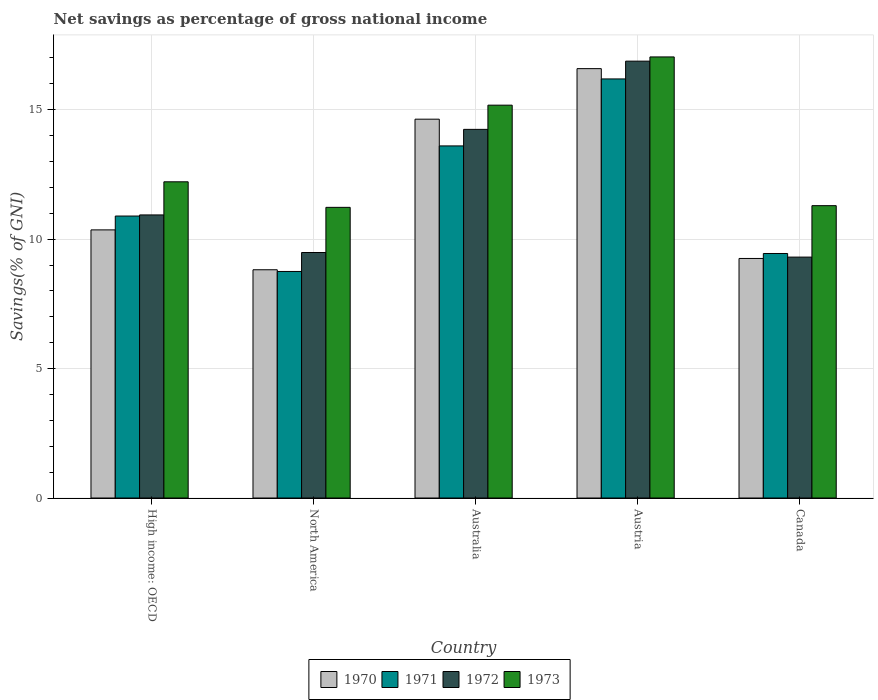How many different coloured bars are there?
Give a very brief answer. 4. How many groups of bars are there?
Keep it short and to the point. 5. Are the number of bars per tick equal to the number of legend labels?
Your response must be concise. Yes. Are the number of bars on each tick of the X-axis equal?
Provide a succinct answer. Yes. How many bars are there on the 4th tick from the left?
Offer a very short reply. 4. How many bars are there on the 3rd tick from the right?
Your answer should be compact. 4. What is the label of the 5th group of bars from the left?
Provide a succinct answer. Canada. In how many cases, is the number of bars for a given country not equal to the number of legend labels?
Provide a succinct answer. 0. What is the total savings in 1972 in Australia?
Ensure brevity in your answer.  14.24. Across all countries, what is the maximum total savings in 1972?
Your answer should be very brief. 16.88. Across all countries, what is the minimum total savings in 1973?
Your response must be concise. 11.23. In which country was the total savings in 1971 maximum?
Your response must be concise. Austria. What is the total total savings in 1970 in the graph?
Offer a very short reply. 59.65. What is the difference between the total savings in 1971 in Austria and that in Canada?
Ensure brevity in your answer.  6.74. What is the difference between the total savings in 1973 in Australia and the total savings in 1970 in High income: OECD?
Make the answer very short. 4.82. What is the average total savings in 1971 per country?
Your response must be concise. 11.78. What is the difference between the total savings of/in 1972 and total savings of/in 1970 in High income: OECD?
Offer a terse response. 0.58. What is the ratio of the total savings in 1970 in Austria to that in High income: OECD?
Your answer should be compact. 1.6. Is the total savings in 1970 in Australia less than that in High income: OECD?
Make the answer very short. No. Is the difference between the total savings in 1972 in Austria and High income: OECD greater than the difference between the total savings in 1970 in Austria and High income: OECD?
Provide a succinct answer. No. What is the difference between the highest and the second highest total savings in 1972?
Your response must be concise. 5.94. What is the difference between the highest and the lowest total savings in 1970?
Give a very brief answer. 7.77. Is it the case that in every country, the sum of the total savings in 1971 and total savings in 1973 is greater than the sum of total savings in 1970 and total savings in 1972?
Your answer should be compact. No. What does the 3rd bar from the right in Canada represents?
Your response must be concise. 1971. Is it the case that in every country, the sum of the total savings in 1971 and total savings in 1973 is greater than the total savings in 1972?
Offer a terse response. Yes. Are all the bars in the graph horizontal?
Give a very brief answer. No. How many countries are there in the graph?
Your response must be concise. 5. What is the difference between two consecutive major ticks on the Y-axis?
Your response must be concise. 5. Are the values on the major ticks of Y-axis written in scientific E-notation?
Ensure brevity in your answer.  No. Does the graph contain grids?
Give a very brief answer. Yes. What is the title of the graph?
Keep it short and to the point. Net savings as percentage of gross national income. What is the label or title of the X-axis?
Offer a very short reply. Country. What is the label or title of the Y-axis?
Offer a very short reply. Savings(% of GNI). What is the Savings(% of GNI) of 1970 in High income: OECD?
Offer a very short reply. 10.36. What is the Savings(% of GNI) in 1971 in High income: OECD?
Offer a very short reply. 10.89. What is the Savings(% of GNI) in 1972 in High income: OECD?
Provide a short and direct response. 10.94. What is the Savings(% of GNI) of 1973 in High income: OECD?
Provide a short and direct response. 12.22. What is the Savings(% of GNI) of 1970 in North America?
Keep it short and to the point. 8.82. What is the Savings(% of GNI) in 1971 in North America?
Ensure brevity in your answer.  8.75. What is the Savings(% of GNI) in 1972 in North America?
Your answer should be very brief. 9.48. What is the Savings(% of GNI) of 1973 in North America?
Ensure brevity in your answer.  11.23. What is the Savings(% of GNI) of 1970 in Australia?
Your answer should be compact. 14.63. What is the Savings(% of GNI) in 1971 in Australia?
Your answer should be compact. 13.6. What is the Savings(% of GNI) of 1972 in Australia?
Your answer should be very brief. 14.24. What is the Savings(% of GNI) in 1973 in Australia?
Your response must be concise. 15.18. What is the Savings(% of GNI) of 1970 in Austria?
Provide a short and direct response. 16.59. What is the Savings(% of GNI) of 1971 in Austria?
Offer a very short reply. 16.19. What is the Savings(% of GNI) in 1972 in Austria?
Make the answer very short. 16.88. What is the Savings(% of GNI) in 1973 in Austria?
Provide a succinct answer. 17.04. What is the Savings(% of GNI) in 1970 in Canada?
Provide a short and direct response. 9.25. What is the Savings(% of GNI) of 1971 in Canada?
Offer a very short reply. 9.45. What is the Savings(% of GNI) in 1972 in Canada?
Offer a terse response. 9.31. What is the Savings(% of GNI) in 1973 in Canada?
Keep it short and to the point. 11.29. Across all countries, what is the maximum Savings(% of GNI) in 1970?
Give a very brief answer. 16.59. Across all countries, what is the maximum Savings(% of GNI) in 1971?
Make the answer very short. 16.19. Across all countries, what is the maximum Savings(% of GNI) in 1972?
Your response must be concise. 16.88. Across all countries, what is the maximum Savings(% of GNI) in 1973?
Your answer should be compact. 17.04. Across all countries, what is the minimum Savings(% of GNI) of 1970?
Provide a succinct answer. 8.82. Across all countries, what is the minimum Savings(% of GNI) in 1971?
Provide a short and direct response. 8.75. Across all countries, what is the minimum Savings(% of GNI) of 1972?
Offer a very short reply. 9.31. Across all countries, what is the minimum Savings(% of GNI) in 1973?
Your answer should be very brief. 11.23. What is the total Savings(% of GNI) in 1970 in the graph?
Provide a short and direct response. 59.65. What is the total Savings(% of GNI) of 1971 in the graph?
Offer a terse response. 58.88. What is the total Savings(% of GNI) of 1972 in the graph?
Keep it short and to the point. 60.84. What is the total Savings(% of GNI) in 1973 in the graph?
Keep it short and to the point. 66.95. What is the difference between the Savings(% of GNI) of 1970 in High income: OECD and that in North America?
Provide a short and direct response. 1.54. What is the difference between the Savings(% of GNI) of 1971 in High income: OECD and that in North America?
Ensure brevity in your answer.  2.14. What is the difference between the Savings(% of GNI) in 1972 in High income: OECD and that in North America?
Provide a succinct answer. 1.45. What is the difference between the Savings(% of GNI) in 1973 in High income: OECD and that in North America?
Keep it short and to the point. 0.99. What is the difference between the Savings(% of GNI) of 1970 in High income: OECD and that in Australia?
Keep it short and to the point. -4.28. What is the difference between the Savings(% of GNI) of 1971 in High income: OECD and that in Australia?
Keep it short and to the point. -2.71. What is the difference between the Savings(% of GNI) of 1972 in High income: OECD and that in Australia?
Make the answer very short. -3.31. What is the difference between the Savings(% of GNI) of 1973 in High income: OECD and that in Australia?
Your answer should be compact. -2.96. What is the difference between the Savings(% of GNI) of 1970 in High income: OECD and that in Austria?
Provide a short and direct response. -6.23. What is the difference between the Savings(% of GNI) in 1971 in High income: OECD and that in Austria?
Provide a succinct answer. -5.3. What is the difference between the Savings(% of GNI) in 1972 in High income: OECD and that in Austria?
Offer a terse response. -5.94. What is the difference between the Savings(% of GNI) of 1973 in High income: OECD and that in Austria?
Keep it short and to the point. -4.82. What is the difference between the Savings(% of GNI) of 1970 in High income: OECD and that in Canada?
Make the answer very short. 1.1. What is the difference between the Savings(% of GNI) in 1971 in High income: OECD and that in Canada?
Offer a terse response. 1.45. What is the difference between the Savings(% of GNI) of 1972 in High income: OECD and that in Canada?
Provide a succinct answer. 1.63. What is the difference between the Savings(% of GNI) of 1973 in High income: OECD and that in Canada?
Offer a terse response. 0.92. What is the difference between the Savings(% of GNI) of 1970 in North America and that in Australia?
Ensure brevity in your answer.  -5.82. What is the difference between the Savings(% of GNI) in 1971 in North America and that in Australia?
Your answer should be compact. -4.85. What is the difference between the Savings(% of GNI) in 1972 in North America and that in Australia?
Your answer should be compact. -4.76. What is the difference between the Savings(% of GNI) in 1973 in North America and that in Australia?
Offer a terse response. -3.95. What is the difference between the Savings(% of GNI) in 1970 in North America and that in Austria?
Offer a terse response. -7.77. What is the difference between the Savings(% of GNI) in 1971 in North America and that in Austria?
Ensure brevity in your answer.  -7.44. What is the difference between the Savings(% of GNI) of 1972 in North America and that in Austria?
Keep it short and to the point. -7.39. What is the difference between the Savings(% of GNI) of 1973 in North America and that in Austria?
Your response must be concise. -5.81. What is the difference between the Savings(% of GNI) in 1970 in North America and that in Canada?
Make the answer very short. -0.44. What is the difference between the Savings(% of GNI) in 1971 in North America and that in Canada?
Provide a short and direct response. -0.69. What is the difference between the Savings(% of GNI) in 1972 in North America and that in Canada?
Make the answer very short. 0.18. What is the difference between the Savings(% of GNI) of 1973 in North America and that in Canada?
Provide a succinct answer. -0.07. What is the difference between the Savings(% of GNI) of 1970 in Australia and that in Austria?
Ensure brevity in your answer.  -1.95. What is the difference between the Savings(% of GNI) in 1971 in Australia and that in Austria?
Make the answer very short. -2.59. What is the difference between the Savings(% of GNI) of 1972 in Australia and that in Austria?
Your answer should be very brief. -2.64. What is the difference between the Savings(% of GNI) in 1973 in Australia and that in Austria?
Offer a terse response. -1.86. What is the difference between the Savings(% of GNI) of 1970 in Australia and that in Canada?
Provide a short and direct response. 5.38. What is the difference between the Savings(% of GNI) of 1971 in Australia and that in Canada?
Your response must be concise. 4.16. What is the difference between the Savings(% of GNI) of 1972 in Australia and that in Canada?
Provide a succinct answer. 4.93. What is the difference between the Savings(% of GNI) of 1973 in Australia and that in Canada?
Keep it short and to the point. 3.88. What is the difference between the Savings(% of GNI) in 1970 in Austria and that in Canada?
Give a very brief answer. 7.33. What is the difference between the Savings(% of GNI) of 1971 in Austria and that in Canada?
Make the answer very short. 6.74. What is the difference between the Savings(% of GNI) in 1972 in Austria and that in Canada?
Give a very brief answer. 7.57. What is the difference between the Savings(% of GNI) of 1973 in Austria and that in Canada?
Offer a terse response. 5.75. What is the difference between the Savings(% of GNI) in 1970 in High income: OECD and the Savings(% of GNI) in 1971 in North America?
Your response must be concise. 1.61. What is the difference between the Savings(% of GNI) in 1970 in High income: OECD and the Savings(% of GNI) in 1972 in North America?
Keep it short and to the point. 0.87. What is the difference between the Savings(% of GNI) in 1970 in High income: OECD and the Savings(% of GNI) in 1973 in North America?
Ensure brevity in your answer.  -0.87. What is the difference between the Savings(% of GNI) of 1971 in High income: OECD and the Savings(% of GNI) of 1972 in North America?
Provide a succinct answer. 1.41. What is the difference between the Savings(% of GNI) in 1971 in High income: OECD and the Savings(% of GNI) in 1973 in North America?
Your answer should be compact. -0.34. What is the difference between the Savings(% of GNI) in 1972 in High income: OECD and the Savings(% of GNI) in 1973 in North America?
Offer a terse response. -0.29. What is the difference between the Savings(% of GNI) in 1970 in High income: OECD and the Savings(% of GNI) in 1971 in Australia?
Your answer should be very brief. -3.24. What is the difference between the Savings(% of GNI) of 1970 in High income: OECD and the Savings(% of GNI) of 1972 in Australia?
Give a very brief answer. -3.88. What is the difference between the Savings(% of GNI) in 1970 in High income: OECD and the Savings(% of GNI) in 1973 in Australia?
Provide a short and direct response. -4.82. What is the difference between the Savings(% of GNI) in 1971 in High income: OECD and the Savings(% of GNI) in 1972 in Australia?
Keep it short and to the point. -3.35. What is the difference between the Savings(% of GNI) of 1971 in High income: OECD and the Savings(% of GNI) of 1973 in Australia?
Offer a very short reply. -4.28. What is the difference between the Savings(% of GNI) in 1972 in High income: OECD and the Savings(% of GNI) in 1973 in Australia?
Provide a succinct answer. -4.24. What is the difference between the Savings(% of GNI) of 1970 in High income: OECD and the Savings(% of GNI) of 1971 in Austria?
Provide a short and direct response. -5.83. What is the difference between the Savings(% of GNI) of 1970 in High income: OECD and the Savings(% of GNI) of 1972 in Austria?
Your answer should be compact. -6.52. What is the difference between the Savings(% of GNI) in 1970 in High income: OECD and the Savings(% of GNI) in 1973 in Austria?
Your response must be concise. -6.68. What is the difference between the Savings(% of GNI) in 1971 in High income: OECD and the Savings(% of GNI) in 1972 in Austria?
Give a very brief answer. -5.98. What is the difference between the Savings(% of GNI) of 1971 in High income: OECD and the Savings(% of GNI) of 1973 in Austria?
Ensure brevity in your answer.  -6.15. What is the difference between the Savings(% of GNI) in 1972 in High income: OECD and the Savings(% of GNI) in 1973 in Austria?
Provide a succinct answer. -6.1. What is the difference between the Savings(% of GNI) in 1970 in High income: OECD and the Savings(% of GNI) in 1971 in Canada?
Provide a succinct answer. 0.91. What is the difference between the Savings(% of GNI) in 1970 in High income: OECD and the Savings(% of GNI) in 1972 in Canada?
Ensure brevity in your answer.  1.05. What is the difference between the Savings(% of GNI) of 1970 in High income: OECD and the Savings(% of GNI) of 1973 in Canada?
Provide a short and direct response. -0.94. What is the difference between the Savings(% of GNI) in 1971 in High income: OECD and the Savings(% of GNI) in 1972 in Canada?
Your answer should be compact. 1.59. What is the difference between the Savings(% of GNI) of 1971 in High income: OECD and the Savings(% of GNI) of 1973 in Canada?
Keep it short and to the point. -0.4. What is the difference between the Savings(% of GNI) in 1972 in High income: OECD and the Savings(% of GNI) in 1973 in Canada?
Provide a short and direct response. -0.36. What is the difference between the Savings(% of GNI) in 1970 in North America and the Savings(% of GNI) in 1971 in Australia?
Make the answer very short. -4.78. What is the difference between the Savings(% of GNI) of 1970 in North America and the Savings(% of GNI) of 1972 in Australia?
Your answer should be compact. -5.42. What is the difference between the Savings(% of GNI) of 1970 in North America and the Savings(% of GNI) of 1973 in Australia?
Offer a terse response. -6.36. What is the difference between the Savings(% of GNI) of 1971 in North America and the Savings(% of GNI) of 1972 in Australia?
Your response must be concise. -5.49. What is the difference between the Savings(% of GNI) in 1971 in North America and the Savings(% of GNI) in 1973 in Australia?
Your response must be concise. -6.42. What is the difference between the Savings(% of GNI) of 1972 in North America and the Savings(% of GNI) of 1973 in Australia?
Offer a very short reply. -5.69. What is the difference between the Savings(% of GNI) of 1970 in North America and the Savings(% of GNI) of 1971 in Austria?
Your response must be concise. -7.37. What is the difference between the Savings(% of GNI) of 1970 in North America and the Savings(% of GNI) of 1972 in Austria?
Your answer should be compact. -8.06. What is the difference between the Savings(% of GNI) in 1970 in North America and the Savings(% of GNI) in 1973 in Austria?
Provide a short and direct response. -8.22. What is the difference between the Savings(% of GNI) in 1971 in North America and the Savings(% of GNI) in 1972 in Austria?
Your answer should be very brief. -8.12. What is the difference between the Savings(% of GNI) of 1971 in North America and the Savings(% of GNI) of 1973 in Austria?
Your answer should be compact. -8.29. What is the difference between the Savings(% of GNI) in 1972 in North America and the Savings(% of GNI) in 1973 in Austria?
Your answer should be very brief. -7.56. What is the difference between the Savings(% of GNI) of 1970 in North America and the Savings(% of GNI) of 1971 in Canada?
Provide a succinct answer. -0.63. What is the difference between the Savings(% of GNI) of 1970 in North America and the Savings(% of GNI) of 1972 in Canada?
Your answer should be compact. -0.49. What is the difference between the Savings(% of GNI) in 1970 in North America and the Savings(% of GNI) in 1973 in Canada?
Provide a succinct answer. -2.48. What is the difference between the Savings(% of GNI) in 1971 in North America and the Savings(% of GNI) in 1972 in Canada?
Keep it short and to the point. -0.55. What is the difference between the Savings(% of GNI) in 1971 in North America and the Savings(% of GNI) in 1973 in Canada?
Make the answer very short. -2.54. What is the difference between the Savings(% of GNI) in 1972 in North America and the Savings(% of GNI) in 1973 in Canada?
Offer a very short reply. -1.81. What is the difference between the Savings(% of GNI) in 1970 in Australia and the Savings(% of GNI) in 1971 in Austria?
Ensure brevity in your answer.  -1.55. What is the difference between the Savings(% of GNI) in 1970 in Australia and the Savings(% of GNI) in 1972 in Austria?
Give a very brief answer. -2.24. What is the difference between the Savings(% of GNI) in 1970 in Australia and the Savings(% of GNI) in 1973 in Austria?
Keep it short and to the point. -2.4. What is the difference between the Savings(% of GNI) in 1971 in Australia and the Savings(% of GNI) in 1972 in Austria?
Your answer should be compact. -3.27. What is the difference between the Savings(% of GNI) of 1971 in Australia and the Savings(% of GNI) of 1973 in Austria?
Give a very brief answer. -3.44. What is the difference between the Savings(% of GNI) in 1972 in Australia and the Savings(% of GNI) in 1973 in Austria?
Provide a succinct answer. -2.8. What is the difference between the Savings(% of GNI) of 1970 in Australia and the Savings(% of GNI) of 1971 in Canada?
Give a very brief answer. 5.19. What is the difference between the Savings(% of GNI) of 1970 in Australia and the Savings(% of GNI) of 1972 in Canada?
Your answer should be very brief. 5.33. What is the difference between the Savings(% of GNI) in 1970 in Australia and the Savings(% of GNI) in 1973 in Canada?
Your answer should be very brief. 3.34. What is the difference between the Savings(% of GNI) in 1971 in Australia and the Savings(% of GNI) in 1972 in Canada?
Your response must be concise. 4.3. What is the difference between the Savings(% of GNI) of 1971 in Australia and the Savings(% of GNI) of 1973 in Canada?
Your response must be concise. 2.31. What is the difference between the Savings(% of GNI) in 1972 in Australia and the Savings(% of GNI) in 1973 in Canada?
Your response must be concise. 2.95. What is the difference between the Savings(% of GNI) in 1970 in Austria and the Savings(% of GNI) in 1971 in Canada?
Your answer should be very brief. 7.14. What is the difference between the Savings(% of GNI) of 1970 in Austria and the Savings(% of GNI) of 1972 in Canada?
Offer a very short reply. 7.28. What is the difference between the Savings(% of GNI) in 1970 in Austria and the Savings(% of GNI) in 1973 in Canada?
Give a very brief answer. 5.29. What is the difference between the Savings(% of GNI) of 1971 in Austria and the Savings(% of GNI) of 1972 in Canada?
Give a very brief answer. 6.88. What is the difference between the Savings(% of GNI) in 1971 in Austria and the Savings(% of GNI) in 1973 in Canada?
Your response must be concise. 4.9. What is the difference between the Savings(% of GNI) of 1972 in Austria and the Savings(% of GNI) of 1973 in Canada?
Your answer should be very brief. 5.58. What is the average Savings(% of GNI) in 1970 per country?
Ensure brevity in your answer.  11.93. What is the average Savings(% of GNI) in 1971 per country?
Ensure brevity in your answer.  11.78. What is the average Savings(% of GNI) in 1972 per country?
Provide a short and direct response. 12.17. What is the average Savings(% of GNI) of 1973 per country?
Offer a terse response. 13.39. What is the difference between the Savings(% of GNI) in 1970 and Savings(% of GNI) in 1971 in High income: OECD?
Provide a short and direct response. -0.53. What is the difference between the Savings(% of GNI) in 1970 and Savings(% of GNI) in 1972 in High income: OECD?
Offer a terse response. -0.58. What is the difference between the Savings(% of GNI) in 1970 and Savings(% of GNI) in 1973 in High income: OECD?
Offer a terse response. -1.86. What is the difference between the Savings(% of GNI) in 1971 and Savings(% of GNI) in 1972 in High income: OECD?
Provide a succinct answer. -0.04. What is the difference between the Savings(% of GNI) in 1971 and Savings(% of GNI) in 1973 in High income: OECD?
Your response must be concise. -1.32. What is the difference between the Savings(% of GNI) of 1972 and Savings(% of GNI) of 1973 in High income: OECD?
Your answer should be very brief. -1.28. What is the difference between the Savings(% of GNI) of 1970 and Savings(% of GNI) of 1971 in North America?
Give a very brief answer. 0.07. What is the difference between the Savings(% of GNI) of 1970 and Savings(% of GNI) of 1972 in North America?
Offer a terse response. -0.67. What is the difference between the Savings(% of GNI) in 1970 and Savings(% of GNI) in 1973 in North America?
Your answer should be very brief. -2.41. What is the difference between the Savings(% of GNI) of 1971 and Savings(% of GNI) of 1972 in North America?
Keep it short and to the point. -0.73. What is the difference between the Savings(% of GNI) in 1971 and Savings(% of GNI) in 1973 in North America?
Your answer should be compact. -2.48. What is the difference between the Savings(% of GNI) in 1972 and Savings(% of GNI) in 1973 in North America?
Ensure brevity in your answer.  -1.74. What is the difference between the Savings(% of GNI) of 1970 and Savings(% of GNI) of 1971 in Australia?
Your answer should be very brief. 1.03. What is the difference between the Savings(% of GNI) in 1970 and Savings(% of GNI) in 1972 in Australia?
Provide a succinct answer. 0.39. What is the difference between the Savings(% of GNI) in 1970 and Savings(% of GNI) in 1973 in Australia?
Provide a succinct answer. -0.54. What is the difference between the Savings(% of GNI) of 1971 and Savings(% of GNI) of 1972 in Australia?
Provide a short and direct response. -0.64. What is the difference between the Savings(% of GNI) in 1971 and Savings(% of GNI) in 1973 in Australia?
Give a very brief answer. -1.57. What is the difference between the Savings(% of GNI) of 1972 and Savings(% of GNI) of 1973 in Australia?
Provide a succinct answer. -0.93. What is the difference between the Savings(% of GNI) in 1970 and Savings(% of GNI) in 1971 in Austria?
Your answer should be very brief. 0.4. What is the difference between the Savings(% of GNI) in 1970 and Savings(% of GNI) in 1972 in Austria?
Make the answer very short. -0.29. What is the difference between the Savings(% of GNI) of 1970 and Savings(% of GNI) of 1973 in Austria?
Your answer should be very brief. -0.45. What is the difference between the Savings(% of GNI) of 1971 and Savings(% of GNI) of 1972 in Austria?
Keep it short and to the point. -0.69. What is the difference between the Savings(% of GNI) of 1971 and Savings(% of GNI) of 1973 in Austria?
Offer a very short reply. -0.85. What is the difference between the Savings(% of GNI) in 1972 and Savings(% of GNI) in 1973 in Austria?
Offer a very short reply. -0.16. What is the difference between the Savings(% of GNI) of 1970 and Savings(% of GNI) of 1971 in Canada?
Offer a very short reply. -0.19. What is the difference between the Savings(% of GNI) in 1970 and Savings(% of GNI) in 1972 in Canada?
Give a very brief answer. -0.05. What is the difference between the Savings(% of GNI) of 1970 and Savings(% of GNI) of 1973 in Canada?
Provide a short and direct response. -2.04. What is the difference between the Savings(% of GNI) in 1971 and Savings(% of GNI) in 1972 in Canada?
Provide a succinct answer. 0.14. What is the difference between the Savings(% of GNI) of 1971 and Savings(% of GNI) of 1973 in Canada?
Ensure brevity in your answer.  -1.85. What is the difference between the Savings(% of GNI) in 1972 and Savings(% of GNI) in 1973 in Canada?
Offer a terse response. -1.99. What is the ratio of the Savings(% of GNI) of 1970 in High income: OECD to that in North America?
Ensure brevity in your answer.  1.17. What is the ratio of the Savings(% of GNI) in 1971 in High income: OECD to that in North America?
Provide a short and direct response. 1.24. What is the ratio of the Savings(% of GNI) of 1972 in High income: OECD to that in North America?
Make the answer very short. 1.15. What is the ratio of the Savings(% of GNI) in 1973 in High income: OECD to that in North America?
Keep it short and to the point. 1.09. What is the ratio of the Savings(% of GNI) of 1970 in High income: OECD to that in Australia?
Offer a very short reply. 0.71. What is the ratio of the Savings(% of GNI) of 1971 in High income: OECD to that in Australia?
Your response must be concise. 0.8. What is the ratio of the Savings(% of GNI) in 1972 in High income: OECD to that in Australia?
Offer a very short reply. 0.77. What is the ratio of the Savings(% of GNI) in 1973 in High income: OECD to that in Australia?
Give a very brief answer. 0.8. What is the ratio of the Savings(% of GNI) in 1970 in High income: OECD to that in Austria?
Keep it short and to the point. 0.62. What is the ratio of the Savings(% of GNI) of 1971 in High income: OECD to that in Austria?
Give a very brief answer. 0.67. What is the ratio of the Savings(% of GNI) of 1972 in High income: OECD to that in Austria?
Your answer should be compact. 0.65. What is the ratio of the Savings(% of GNI) in 1973 in High income: OECD to that in Austria?
Provide a short and direct response. 0.72. What is the ratio of the Savings(% of GNI) in 1970 in High income: OECD to that in Canada?
Provide a short and direct response. 1.12. What is the ratio of the Savings(% of GNI) of 1971 in High income: OECD to that in Canada?
Provide a short and direct response. 1.15. What is the ratio of the Savings(% of GNI) in 1972 in High income: OECD to that in Canada?
Provide a succinct answer. 1.18. What is the ratio of the Savings(% of GNI) of 1973 in High income: OECD to that in Canada?
Provide a short and direct response. 1.08. What is the ratio of the Savings(% of GNI) in 1970 in North America to that in Australia?
Give a very brief answer. 0.6. What is the ratio of the Savings(% of GNI) in 1971 in North America to that in Australia?
Your response must be concise. 0.64. What is the ratio of the Savings(% of GNI) in 1972 in North America to that in Australia?
Your answer should be compact. 0.67. What is the ratio of the Savings(% of GNI) in 1973 in North America to that in Australia?
Offer a very short reply. 0.74. What is the ratio of the Savings(% of GNI) in 1970 in North America to that in Austria?
Your answer should be very brief. 0.53. What is the ratio of the Savings(% of GNI) of 1971 in North America to that in Austria?
Keep it short and to the point. 0.54. What is the ratio of the Savings(% of GNI) in 1972 in North America to that in Austria?
Make the answer very short. 0.56. What is the ratio of the Savings(% of GNI) in 1973 in North America to that in Austria?
Your answer should be compact. 0.66. What is the ratio of the Savings(% of GNI) in 1970 in North America to that in Canada?
Offer a very short reply. 0.95. What is the ratio of the Savings(% of GNI) in 1971 in North America to that in Canada?
Give a very brief answer. 0.93. What is the ratio of the Savings(% of GNI) in 1972 in North America to that in Canada?
Your answer should be very brief. 1.02. What is the ratio of the Savings(% of GNI) of 1970 in Australia to that in Austria?
Offer a very short reply. 0.88. What is the ratio of the Savings(% of GNI) in 1971 in Australia to that in Austria?
Keep it short and to the point. 0.84. What is the ratio of the Savings(% of GNI) in 1972 in Australia to that in Austria?
Your response must be concise. 0.84. What is the ratio of the Savings(% of GNI) of 1973 in Australia to that in Austria?
Offer a terse response. 0.89. What is the ratio of the Savings(% of GNI) in 1970 in Australia to that in Canada?
Make the answer very short. 1.58. What is the ratio of the Savings(% of GNI) of 1971 in Australia to that in Canada?
Give a very brief answer. 1.44. What is the ratio of the Savings(% of GNI) of 1972 in Australia to that in Canada?
Your response must be concise. 1.53. What is the ratio of the Savings(% of GNI) in 1973 in Australia to that in Canada?
Make the answer very short. 1.34. What is the ratio of the Savings(% of GNI) of 1970 in Austria to that in Canada?
Your answer should be very brief. 1.79. What is the ratio of the Savings(% of GNI) in 1971 in Austria to that in Canada?
Keep it short and to the point. 1.71. What is the ratio of the Savings(% of GNI) in 1972 in Austria to that in Canada?
Offer a very short reply. 1.81. What is the ratio of the Savings(% of GNI) in 1973 in Austria to that in Canada?
Your answer should be very brief. 1.51. What is the difference between the highest and the second highest Savings(% of GNI) of 1970?
Keep it short and to the point. 1.95. What is the difference between the highest and the second highest Savings(% of GNI) in 1971?
Your answer should be compact. 2.59. What is the difference between the highest and the second highest Savings(% of GNI) of 1972?
Offer a very short reply. 2.64. What is the difference between the highest and the second highest Savings(% of GNI) in 1973?
Offer a very short reply. 1.86. What is the difference between the highest and the lowest Savings(% of GNI) in 1970?
Keep it short and to the point. 7.77. What is the difference between the highest and the lowest Savings(% of GNI) of 1971?
Provide a succinct answer. 7.44. What is the difference between the highest and the lowest Savings(% of GNI) of 1972?
Ensure brevity in your answer.  7.57. What is the difference between the highest and the lowest Savings(% of GNI) in 1973?
Your answer should be very brief. 5.81. 